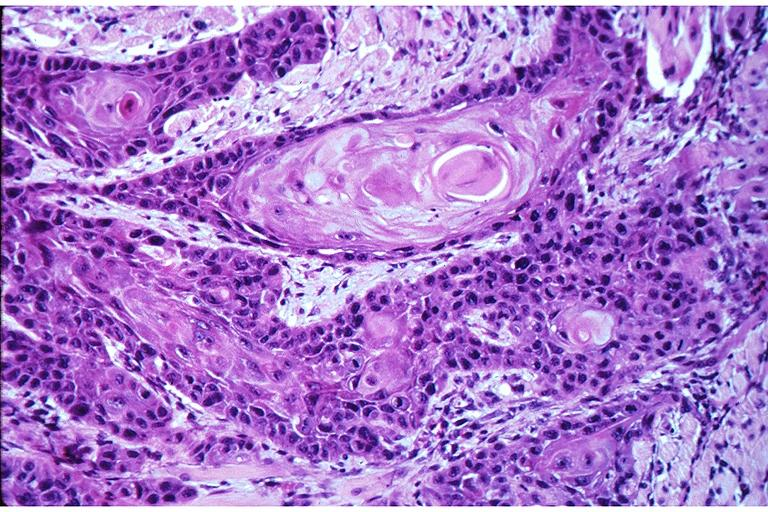where is this?
Answer the question using a single word or phrase. Oral 